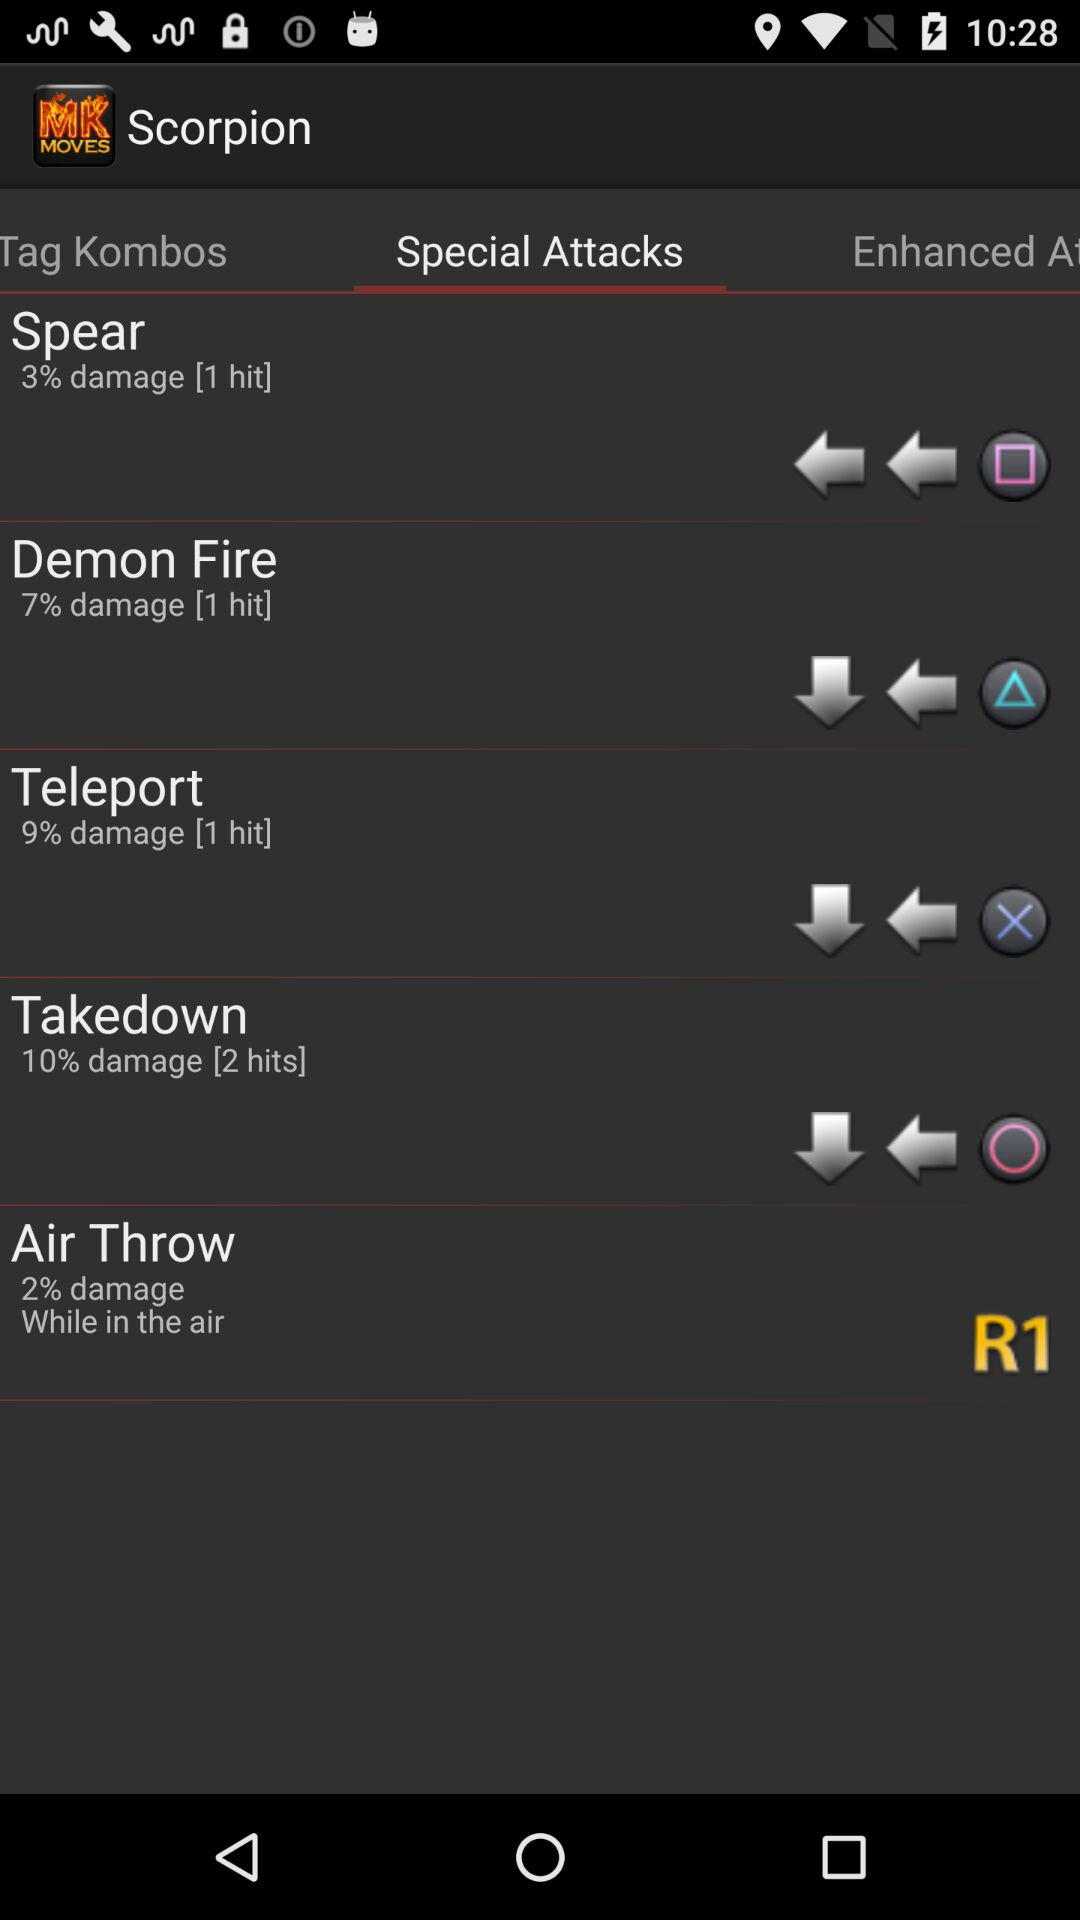What is the damage percentage of "Teleport"? The damage percentage is 9. 